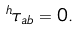Convert formula to latex. <formula><loc_0><loc_0><loc_500><loc_500>^ { h } \tau _ { a b } = 0 .</formula> 